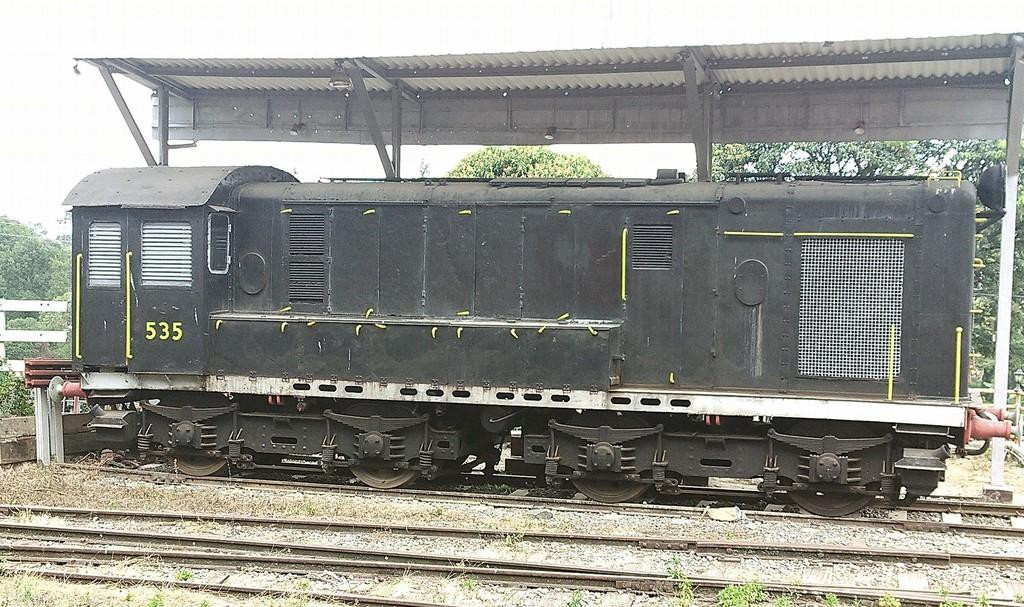What is the main subject in the foreground of the image? There is a train engine in the foreground of the image. What is the train engine's position in relation to the track? The train engine is on a track. What can be seen in the background of the image? There is a platform, trees, and the sky visible in the background of the image. Can you determine the time of day based on the image? The image is likely taken during the day, as the sky is visible and not dark. What type of addition problem can be solved using the train engine in the image? There is no addition problem present in the image, as it is a photograph of a train engine on a track. 